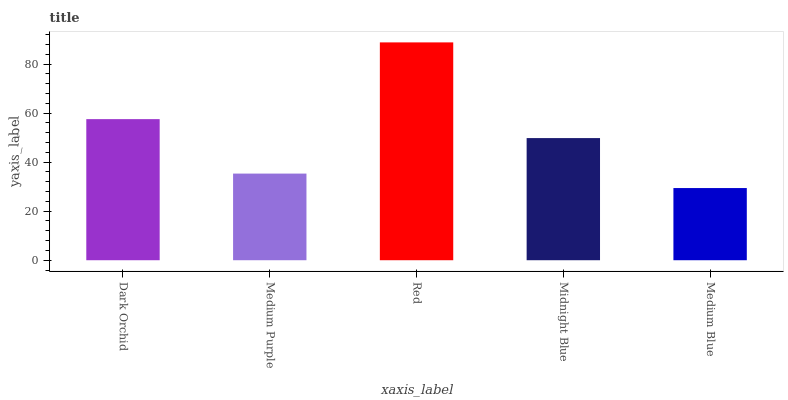Is Medium Blue the minimum?
Answer yes or no. Yes. Is Red the maximum?
Answer yes or no. Yes. Is Medium Purple the minimum?
Answer yes or no. No. Is Medium Purple the maximum?
Answer yes or no. No. Is Dark Orchid greater than Medium Purple?
Answer yes or no. Yes. Is Medium Purple less than Dark Orchid?
Answer yes or no. Yes. Is Medium Purple greater than Dark Orchid?
Answer yes or no. No. Is Dark Orchid less than Medium Purple?
Answer yes or no. No. Is Midnight Blue the high median?
Answer yes or no. Yes. Is Midnight Blue the low median?
Answer yes or no. Yes. Is Dark Orchid the high median?
Answer yes or no. No. Is Dark Orchid the low median?
Answer yes or no. No. 